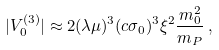Convert formula to latex. <formula><loc_0><loc_0><loc_500><loc_500>| V ^ { ( 3 ) } _ { 0 } | \approx 2 ( \lambda \mu ) ^ { 3 } ( c \sigma _ { 0 } ) ^ { 3 } \xi ^ { 2 } \frac { m _ { 0 } ^ { 2 } } { m _ { P } } \, ,</formula> 